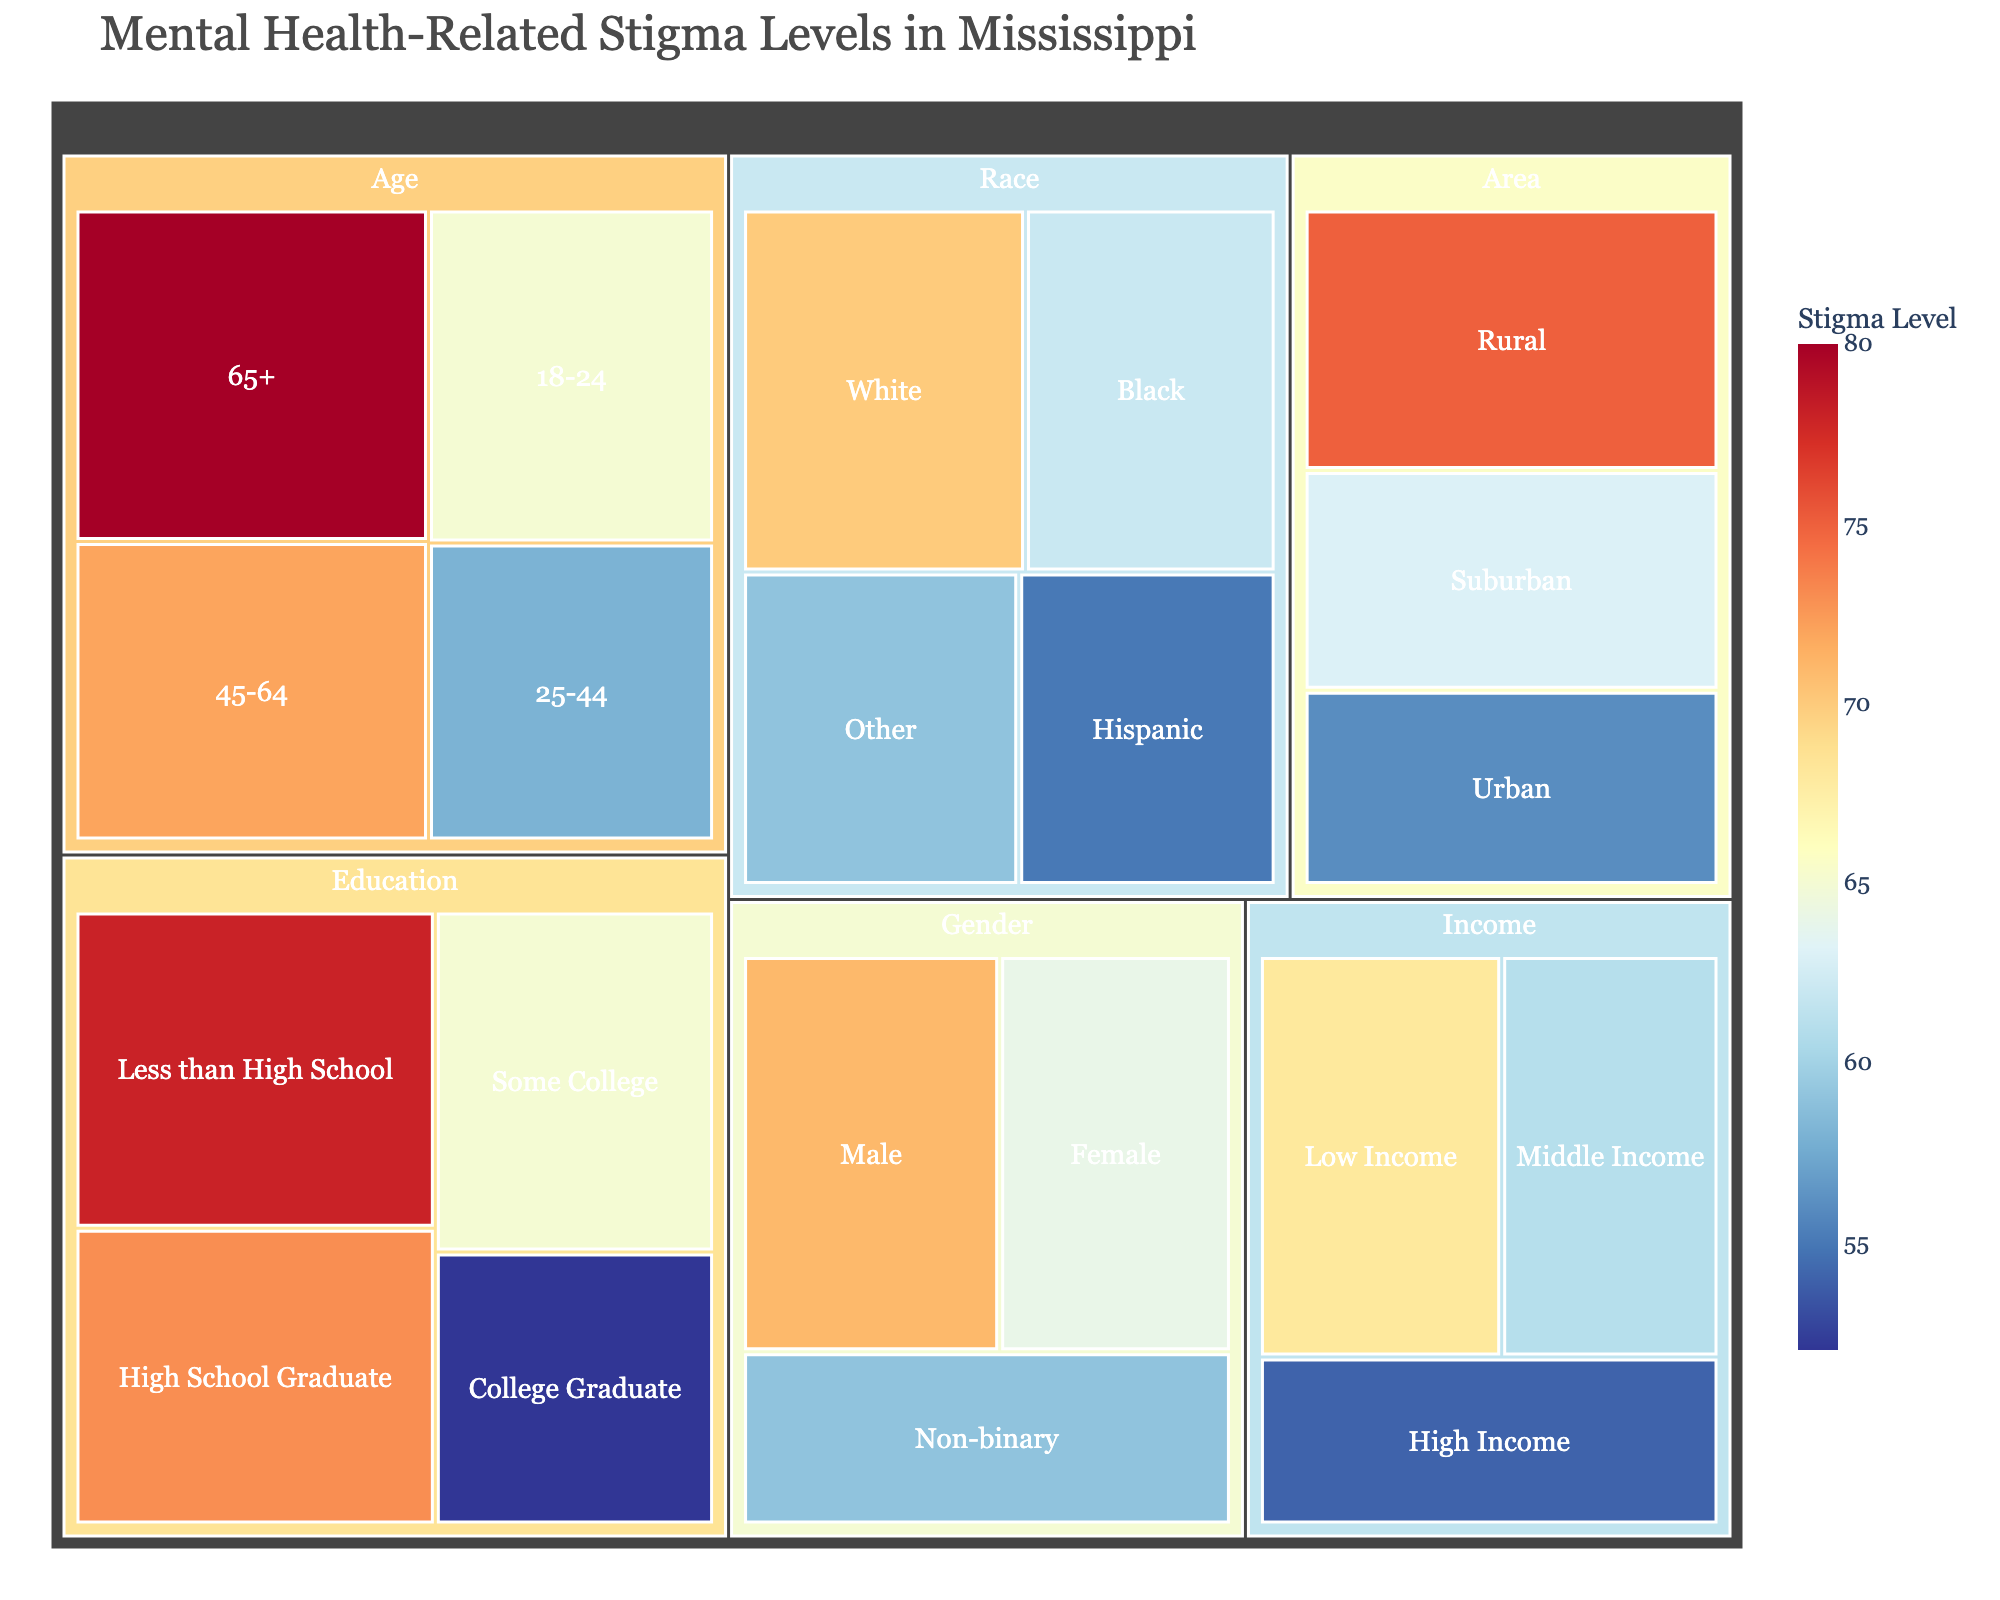What is the stigma level for individuals aged 65+? Look inside the Age category in the treemap for the value associated with the 65+ subgroup, which is displayed as 80.
Answer: 80 Which demographic subgroup has the highest stigma level according to the treemap? Survey all the stigma level values in the treemap and find the maximum among them, which is 80. This is associated with the Age 65+ subgroup.
Answer: Age 65+ How does the stigma level of individuals with a college degree compare to those with less than a high school education? Refer to the Education category and compare the stigma levels. College Graduate is 52, and Less than High School is 78. 78 is higher than 52 by 26.
Answer: 26 less What is the stigma level difference between Urban and Rural areas? Look at the Area category for the stigma levels of Urban (56) and Rural (75) and subtract 56 from 75 to get the difference, which is 19.
Answer: 19 Identify the subgroup with the lowest stigma level within the Income category. Explore the subgroups within the Income category and identify that High Income has the lowest stigma level at 54.
Answer: High Income Which demographic group by Race has the highest stigma level? Within the Race category, compare the stigma levels and see that White has the highest value at 70.
Answer: White What is the sum of stigma levels for all subgroups within the Gender category? Add up the stigma levels for Male (71), Female (64), and Non-binary (59), resulting in 194.
Answer: 194 On average, what is the stigma level across all education subgroups? Sum the stigma levels for all education subgroups [Less than High School (78), High School Graduate (73), Some College (65), and College Graduate (52)] and then divide by the number of subgroups (4), leading to (78 + 73 + 65 + 52) / 4 = 67.
Answer: 67 How does the stigma level for those aged 18-24 compare to those aged 25-44 and aged 45-64? Check the Age category for the stigma levels of 18-24 (65), 25-44 (58), and 45-64 (72). Among these, 18-24 is higher than 25-44 by 7 and lower than 45-64 by 7.
Answer: Higher than 25-44, lower than 45-64 What is the combined stigma level for the racial subgroups Hispanic and Other? Add the stigma levels of the Hispanic (55) and Other (59) racial subgroups, resulting in a combined value of 114.
Answer: 114 